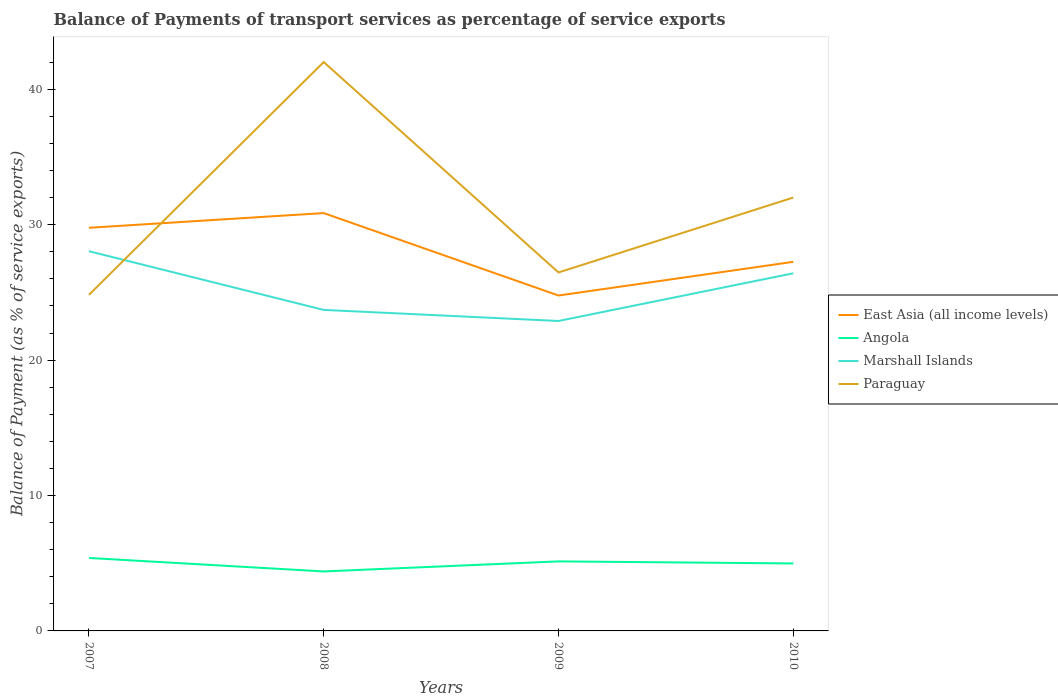Across all years, what is the maximum balance of payments of transport services in Paraguay?
Keep it short and to the point. 24.82. What is the total balance of payments of transport services in Marshall Islands in the graph?
Your answer should be compact. 1.63. What is the difference between the highest and the second highest balance of payments of transport services in East Asia (all income levels)?
Your answer should be compact. 6.09. Is the balance of payments of transport services in East Asia (all income levels) strictly greater than the balance of payments of transport services in Paraguay over the years?
Your answer should be very brief. No. How many lines are there?
Give a very brief answer. 4. Are the values on the major ticks of Y-axis written in scientific E-notation?
Your response must be concise. No. How are the legend labels stacked?
Make the answer very short. Vertical. What is the title of the graph?
Your answer should be compact. Balance of Payments of transport services as percentage of service exports. What is the label or title of the X-axis?
Your answer should be very brief. Years. What is the label or title of the Y-axis?
Keep it short and to the point. Balance of Payment (as % of service exports). What is the Balance of Payment (as % of service exports) in East Asia (all income levels) in 2007?
Provide a short and direct response. 29.78. What is the Balance of Payment (as % of service exports) of Angola in 2007?
Provide a short and direct response. 5.39. What is the Balance of Payment (as % of service exports) in Marshall Islands in 2007?
Your response must be concise. 28.05. What is the Balance of Payment (as % of service exports) of Paraguay in 2007?
Give a very brief answer. 24.82. What is the Balance of Payment (as % of service exports) in East Asia (all income levels) in 2008?
Give a very brief answer. 30.86. What is the Balance of Payment (as % of service exports) of Angola in 2008?
Make the answer very short. 4.39. What is the Balance of Payment (as % of service exports) of Marshall Islands in 2008?
Provide a succinct answer. 23.71. What is the Balance of Payment (as % of service exports) in Paraguay in 2008?
Give a very brief answer. 42.02. What is the Balance of Payment (as % of service exports) in East Asia (all income levels) in 2009?
Make the answer very short. 24.77. What is the Balance of Payment (as % of service exports) of Angola in 2009?
Offer a terse response. 5.14. What is the Balance of Payment (as % of service exports) in Marshall Islands in 2009?
Your answer should be compact. 22.89. What is the Balance of Payment (as % of service exports) of Paraguay in 2009?
Provide a short and direct response. 26.48. What is the Balance of Payment (as % of service exports) in East Asia (all income levels) in 2010?
Give a very brief answer. 27.26. What is the Balance of Payment (as % of service exports) of Angola in 2010?
Make the answer very short. 4.98. What is the Balance of Payment (as % of service exports) in Marshall Islands in 2010?
Give a very brief answer. 26.41. What is the Balance of Payment (as % of service exports) of Paraguay in 2010?
Ensure brevity in your answer.  32.01. Across all years, what is the maximum Balance of Payment (as % of service exports) of East Asia (all income levels)?
Offer a terse response. 30.86. Across all years, what is the maximum Balance of Payment (as % of service exports) in Angola?
Keep it short and to the point. 5.39. Across all years, what is the maximum Balance of Payment (as % of service exports) of Marshall Islands?
Offer a terse response. 28.05. Across all years, what is the maximum Balance of Payment (as % of service exports) of Paraguay?
Make the answer very short. 42.02. Across all years, what is the minimum Balance of Payment (as % of service exports) in East Asia (all income levels)?
Provide a succinct answer. 24.77. Across all years, what is the minimum Balance of Payment (as % of service exports) of Angola?
Make the answer very short. 4.39. Across all years, what is the minimum Balance of Payment (as % of service exports) of Marshall Islands?
Give a very brief answer. 22.89. Across all years, what is the minimum Balance of Payment (as % of service exports) of Paraguay?
Give a very brief answer. 24.82. What is the total Balance of Payment (as % of service exports) in East Asia (all income levels) in the graph?
Provide a succinct answer. 112.67. What is the total Balance of Payment (as % of service exports) in Angola in the graph?
Provide a short and direct response. 19.9. What is the total Balance of Payment (as % of service exports) of Marshall Islands in the graph?
Ensure brevity in your answer.  101.06. What is the total Balance of Payment (as % of service exports) in Paraguay in the graph?
Keep it short and to the point. 125.32. What is the difference between the Balance of Payment (as % of service exports) of East Asia (all income levels) in 2007 and that in 2008?
Give a very brief answer. -1.09. What is the difference between the Balance of Payment (as % of service exports) in Angola in 2007 and that in 2008?
Give a very brief answer. 1. What is the difference between the Balance of Payment (as % of service exports) in Marshall Islands in 2007 and that in 2008?
Your response must be concise. 4.34. What is the difference between the Balance of Payment (as % of service exports) of Paraguay in 2007 and that in 2008?
Offer a very short reply. -17.2. What is the difference between the Balance of Payment (as % of service exports) of East Asia (all income levels) in 2007 and that in 2009?
Your answer should be very brief. 5. What is the difference between the Balance of Payment (as % of service exports) in Angola in 2007 and that in 2009?
Keep it short and to the point. 0.25. What is the difference between the Balance of Payment (as % of service exports) in Marshall Islands in 2007 and that in 2009?
Give a very brief answer. 5.15. What is the difference between the Balance of Payment (as % of service exports) of Paraguay in 2007 and that in 2009?
Keep it short and to the point. -1.65. What is the difference between the Balance of Payment (as % of service exports) of East Asia (all income levels) in 2007 and that in 2010?
Offer a terse response. 2.51. What is the difference between the Balance of Payment (as % of service exports) of Angola in 2007 and that in 2010?
Offer a very short reply. 0.41. What is the difference between the Balance of Payment (as % of service exports) in Marshall Islands in 2007 and that in 2010?
Your response must be concise. 1.63. What is the difference between the Balance of Payment (as % of service exports) in Paraguay in 2007 and that in 2010?
Provide a short and direct response. -7.19. What is the difference between the Balance of Payment (as % of service exports) in East Asia (all income levels) in 2008 and that in 2009?
Give a very brief answer. 6.09. What is the difference between the Balance of Payment (as % of service exports) of Angola in 2008 and that in 2009?
Your response must be concise. -0.74. What is the difference between the Balance of Payment (as % of service exports) in Marshall Islands in 2008 and that in 2009?
Offer a very short reply. 0.82. What is the difference between the Balance of Payment (as % of service exports) in Paraguay in 2008 and that in 2009?
Keep it short and to the point. 15.54. What is the difference between the Balance of Payment (as % of service exports) of East Asia (all income levels) in 2008 and that in 2010?
Your response must be concise. 3.6. What is the difference between the Balance of Payment (as % of service exports) in Angola in 2008 and that in 2010?
Your answer should be compact. -0.59. What is the difference between the Balance of Payment (as % of service exports) of Marshall Islands in 2008 and that in 2010?
Give a very brief answer. -2.7. What is the difference between the Balance of Payment (as % of service exports) of Paraguay in 2008 and that in 2010?
Your answer should be compact. 10.01. What is the difference between the Balance of Payment (as % of service exports) of East Asia (all income levels) in 2009 and that in 2010?
Ensure brevity in your answer.  -2.49. What is the difference between the Balance of Payment (as % of service exports) in Angola in 2009 and that in 2010?
Your answer should be very brief. 0.15. What is the difference between the Balance of Payment (as % of service exports) of Marshall Islands in 2009 and that in 2010?
Ensure brevity in your answer.  -3.52. What is the difference between the Balance of Payment (as % of service exports) of Paraguay in 2009 and that in 2010?
Your answer should be very brief. -5.53. What is the difference between the Balance of Payment (as % of service exports) of East Asia (all income levels) in 2007 and the Balance of Payment (as % of service exports) of Angola in 2008?
Your answer should be very brief. 25.38. What is the difference between the Balance of Payment (as % of service exports) in East Asia (all income levels) in 2007 and the Balance of Payment (as % of service exports) in Marshall Islands in 2008?
Give a very brief answer. 6.07. What is the difference between the Balance of Payment (as % of service exports) in East Asia (all income levels) in 2007 and the Balance of Payment (as % of service exports) in Paraguay in 2008?
Offer a very short reply. -12.24. What is the difference between the Balance of Payment (as % of service exports) of Angola in 2007 and the Balance of Payment (as % of service exports) of Marshall Islands in 2008?
Your response must be concise. -18.32. What is the difference between the Balance of Payment (as % of service exports) in Angola in 2007 and the Balance of Payment (as % of service exports) in Paraguay in 2008?
Keep it short and to the point. -36.63. What is the difference between the Balance of Payment (as % of service exports) in Marshall Islands in 2007 and the Balance of Payment (as % of service exports) in Paraguay in 2008?
Your answer should be very brief. -13.97. What is the difference between the Balance of Payment (as % of service exports) of East Asia (all income levels) in 2007 and the Balance of Payment (as % of service exports) of Angola in 2009?
Keep it short and to the point. 24.64. What is the difference between the Balance of Payment (as % of service exports) in East Asia (all income levels) in 2007 and the Balance of Payment (as % of service exports) in Marshall Islands in 2009?
Your answer should be very brief. 6.88. What is the difference between the Balance of Payment (as % of service exports) of East Asia (all income levels) in 2007 and the Balance of Payment (as % of service exports) of Paraguay in 2009?
Your answer should be compact. 3.3. What is the difference between the Balance of Payment (as % of service exports) of Angola in 2007 and the Balance of Payment (as % of service exports) of Marshall Islands in 2009?
Ensure brevity in your answer.  -17.5. What is the difference between the Balance of Payment (as % of service exports) of Angola in 2007 and the Balance of Payment (as % of service exports) of Paraguay in 2009?
Your response must be concise. -21.09. What is the difference between the Balance of Payment (as % of service exports) of Marshall Islands in 2007 and the Balance of Payment (as % of service exports) of Paraguay in 2009?
Give a very brief answer. 1.57. What is the difference between the Balance of Payment (as % of service exports) of East Asia (all income levels) in 2007 and the Balance of Payment (as % of service exports) of Angola in 2010?
Offer a very short reply. 24.79. What is the difference between the Balance of Payment (as % of service exports) in East Asia (all income levels) in 2007 and the Balance of Payment (as % of service exports) in Marshall Islands in 2010?
Offer a very short reply. 3.36. What is the difference between the Balance of Payment (as % of service exports) in East Asia (all income levels) in 2007 and the Balance of Payment (as % of service exports) in Paraguay in 2010?
Provide a succinct answer. -2.23. What is the difference between the Balance of Payment (as % of service exports) of Angola in 2007 and the Balance of Payment (as % of service exports) of Marshall Islands in 2010?
Give a very brief answer. -21.02. What is the difference between the Balance of Payment (as % of service exports) in Angola in 2007 and the Balance of Payment (as % of service exports) in Paraguay in 2010?
Offer a terse response. -26.62. What is the difference between the Balance of Payment (as % of service exports) in Marshall Islands in 2007 and the Balance of Payment (as % of service exports) in Paraguay in 2010?
Provide a succinct answer. -3.96. What is the difference between the Balance of Payment (as % of service exports) of East Asia (all income levels) in 2008 and the Balance of Payment (as % of service exports) of Angola in 2009?
Provide a short and direct response. 25.73. What is the difference between the Balance of Payment (as % of service exports) in East Asia (all income levels) in 2008 and the Balance of Payment (as % of service exports) in Marshall Islands in 2009?
Your answer should be compact. 7.97. What is the difference between the Balance of Payment (as % of service exports) of East Asia (all income levels) in 2008 and the Balance of Payment (as % of service exports) of Paraguay in 2009?
Your answer should be very brief. 4.39. What is the difference between the Balance of Payment (as % of service exports) in Angola in 2008 and the Balance of Payment (as % of service exports) in Marshall Islands in 2009?
Your response must be concise. -18.5. What is the difference between the Balance of Payment (as % of service exports) of Angola in 2008 and the Balance of Payment (as % of service exports) of Paraguay in 2009?
Your response must be concise. -22.08. What is the difference between the Balance of Payment (as % of service exports) in Marshall Islands in 2008 and the Balance of Payment (as % of service exports) in Paraguay in 2009?
Offer a very short reply. -2.77. What is the difference between the Balance of Payment (as % of service exports) in East Asia (all income levels) in 2008 and the Balance of Payment (as % of service exports) in Angola in 2010?
Your answer should be very brief. 25.88. What is the difference between the Balance of Payment (as % of service exports) in East Asia (all income levels) in 2008 and the Balance of Payment (as % of service exports) in Marshall Islands in 2010?
Your response must be concise. 4.45. What is the difference between the Balance of Payment (as % of service exports) in East Asia (all income levels) in 2008 and the Balance of Payment (as % of service exports) in Paraguay in 2010?
Offer a very short reply. -1.15. What is the difference between the Balance of Payment (as % of service exports) in Angola in 2008 and the Balance of Payment (as % of service exports) in Marshall Islands in 2010?
Your response must be concise. -22.02. What is the difference between the Balance of Payment (as % of service exports) of Angola in 2008 and the Balance of Payment (as % of service exports) of Paraguay in 2010?
Provide a short and direct response. -27.62. What is the difference between the Balance of Payment (as % of service exports) in Marshall Islands in 2008 and the Balance of Payment (as % of service exports) in Paraguay in 2010?
Give a very brief answer. -8.3. What is the difference between the Balance of Payment (as % of service exports) in East Asia (all income levels) in 2009 and the Balance of Payment (as % of service exports) in Angola in 2010?
Your answer should be compact. 19.79. What is the difference between the Balance of Payment (as % of service exports) in East Asia (all income levels) in 2009 and the Balance of Payment (as % of service exports) in Marshall Islands in 2010?
Your response must be concise. -1.64. What is the difference between the Balance of Payment (as % of service exports) in East Asia (all income levels) in 2009 and the Balance of Payment (as % of service exports) in Paraguay in 2010?
Give a very brief answer. -7.24. What is the difference between the Balance of Payment (as % of service exports) in Angola in 2009 and the Balance of Payment (as % of service exports) in Marshall Islands in 2010?
Give a very brief answer. -21.28. What is the difference between the Balance of Payment (as % of service exports) of Angola in 2009 and the Balance of Payment (as % of service exports) of Paraguay in 2010?
Ensure brevity in your answer.  -26.87. What is the difference between the Balance of Payment (as % of service exports) of Marshall Islands in 2009 and the Balance of Payment (as % of service exports) of Paraguay in 2010?
Provide a succinct answer. -9.12. What is the average Balance of Payment (as % of service exports) in East Asia (all income levels) per year?
Your response must be concise. 28.17. What is the average Balance of Payment (as % of service exports) of Angola per year?
Your answer should be compact. 4.98. What is the average Balance of Payment (as % of service exports) of Marshall Islands per year?
Your response must be concise. 25.27. What is the average Balance of Payment (as % of service exports) in Paraguay per year?
Offer a very short reply. 31.33. In the year 2007, what is the difference between the Balance of Payment (as % of service exports) of East Asia (all income levels) and Balance of Payment (as % of service exports) of Angola?
Keep it short and to the point. 24.39. In the year 2007, what is the difference between the Balance of Payment (as % of service exports) of East Asia (all income levels) and Balance of Payment (as % of service exports) of Marshall Islands?
Your answer should be very brief. 1.73. In the year 2007, what is the difference between the Balance of Payment (as % of service exports) of East Asia (all income levels) and Balance of Payment (as % of service exports) of Paraguay?
Make the answer very short. 4.95. In the year 2007, what is the difference between the Balance of Payment (as % of service exports) in Angola and Balance of Payment (as % of service exports) in Marshall Islands?
Your response must be concise. -22.66. In the year 2007, what is the difference between the Balance of Payment (as % of service exports) in Angola and Balance of Payment (as % of service exports) in Paraguay?
Your answer should be very brief. -19.43. In the year 2007, what is the difference between the Balance of Payment (as % of service exports) of Marshall Islands and Balance of Payment (as % of service exports) of Paraguay?
Give a very brief answer. 3.22. In the year 2008, what is the difference between the Balance of Payment (as % of service exports) in East Asia (all income levels) and Balance of Payment (as % of service exports) in Angola?
Make the answer very short. 26.47. In the year 2008, what is the difference between the Balance of Payment (as % of service exports) in East Asia (all income levels) and Balance of Payment (as % of service exports) in Marshall Islands?
Make the answer very short. 7.15. In the year 2008, what is the difference between the Balance of Payment (as % of service exports) of East Asia (all income levels) and Balance of Payment (as % of service exports) of Paraguay?
Provide a short and direct response. -11.16. In the year 2008, what is the difference between the Balance of Payment (as % of service exports) of Angola and Balance of Payment (as % of service exports) of Marshall Islands?
Keep it short and to the point. -19.32. In the year 2008, what is the difference between the Balance of Payment (as % of service exports) in Angola and Balance of Payment (as % of service exports) in Paraguay?
Offer a terse response. -37.62. In the year 2008, what is the difference between the Balance of Payment (as % of service exports) in Marshall Islands and Balance of Payment (as % of service exports) in Paraguay?
Your response must be concise. -18.31. In the year 2009, what is the difference between the Balance of Payment (as % of service exports) of East Asia (all income levels) and Balance of Payment (as % of service exports) of Angola?
Provide a succinct answer. 19.64. In the year 2009, what is the difference between the Balance of Payment (as % of service exports) of East Asia (all income levels) and Balance of Payment (as % of service exports) of Marshall Islands?
Give a very brief answer. 1.88. In the year 2009, what is the difference between the Balance of Payment (as % of service exports) of East Asia (all income levels) and Balance of Payment (as % of service exports) of Paraguay?
Your answer should be very brief. -1.7. In the year 2009, what is the difference between the Balance of Payment (as % of service exports) of Angola and Balance of Payment (as % of service exports) of Marshall Islands?
Your answer should be very brief. -17.76. In the year 2009, what is the difference between the Balance of Payment (as % of service exports) in Angola and Balance of Payment (as % of service exports) in Paraguay?
Provide a short and direct response. -21.34. In the year 2009, what is the difference between the Balance of Payment (as % of service exports) in Marshall Islands and Balance of Payment (as % of service exports) in Paraguay?
Make the answer very short. -3.58. In the year 2010, what is the difference between the Balance of Payment (as % of service exports) in East Asia (all income levels) and Balance of Payment (as % of service exports) in Angola?
Keep it short and to the point. 22.28. In the year 2010, what is the difference between the Balance of Payment (as % of service exports) in East Asia (all income levels) and Balance of Payment (as % of service exports) in Marshall Islands?
Make the answer very short. 0.85. In the year 2010, what is the difference between the Balance of Payment (as % of service exports) in East Asia (all income levels) and Balance of Payment (as % of service exports) in Paraguay?
Give a very brief answer. -4.75. In the year 2010, what is the difference between the Balance of Payment (as % of service exports) in Angola and Balance of Payment (as % of service exports) in Marshall Islands?
Your response must be concise. -21.43. In the year 2010, what is the difference between the Balance of Payment (as % of service exports) of Angola and Balance of Payment (as % of service exports) of Paraguay?
Provide a succinct answer. -27.02. In the year 2010, what is the difference between the Balance of Payment (as % of service exports) of Marshall Islands and Balance of Payment (as % of service exports) of Paraguay?
Offer a very short reply. -5.59. What is the ratio of the Balance of Payment (as % of service exports) of East Asia (all income levels) in 2007 to that in 2008?
Provide a short and direct response. 0.96. What is the ratio of the Balance of Payment (as % of service exports) in Angola in 2007 to that in 2008?
Keep it short and to the point. 1.23. What is the ratio of the Balance of Payment (as % of service exports) in Marshall Islands in 2007 to that in 2008?
Offer a terse response. 1.18. What is the ratio of the Balance of Payment (as % of service exports) in Paraguay in 2007 to that in 2008?
Make the answer very short. 0.59. What is the ratio of the Balance of Payment (as % of service exports) in East Asia (all income levels) in 2007 to that in 2009?
Give a very brief answer. 1.2. What is the ratio of the Balance of Payment (as % of service exports) of Angola in 2007 to that in 2009?
Your response must be concise. 1.05. What is the ratio of the Balance of Payment (as % of service exports) of Marshall Islands in 2007 to that in 2009?
Ensure brevity in your answer.  1.23. What is the ratio of the Balance of Payment (as % of service exports) in East Asia (all income levels) in 2007 to that in 2010?
Your answer should be very brief. 1.09. What is the ratio of the Balance of Payment (as % of service exports) in Angola in 2007 to that in 2010?
Give a very brief answer. 1.08. What is the ratio of the Balance of Payment (as % of service exports) in Marshall Islands in 2007 to that in 2010?
Your answer should be very brief. 1.06. What is the ratio of the Balance of Payment (as % of service exports) in Paraguay in 2007 to that in 2010?
Ensure brevity in your answer.  0.78. What is the ratio of the Balance of Payment (as % of service exports) in East Asia (all income levels) in 2008 to that in 2009?
Ensure brevity in your answer.  1.25. What is the ratio of the Balance of Payment (as % of service exports) in Angola in 2008 to that in 2009?
Offer a terse response. 0.86. What is the ratio of the Balance of Payment (as % of service exports) of Marshall Islands in 2008 to that in 2009?
Your answer should be very brief. 1.04. What is the ratio of the Balance of Payment (as % of service exports) in Paraguay in 2008 to that in 2009?
Make the answer very short. 1.59. What is the ratio of the Balance of Payment (as % of service exports) of East Asia (all income levels) in 2008 to that in 2010?
Offer a very short reply. 1.13. What is the ratio of the Balance of Payment (as % of service exports) of Angola in 2008 to that in 2010?
Keep it short and to the point. 0.88. What is the ratio of the Balance of Payment (as % of service exports) of Marshall Islands in 2008 to that in 2010?
Your response must be concise. 0.9. What is the ratio of the Balance of Payment (as % of service exports) in Paraguay in 2008 to that in 2010?
Make the answer very short. 1.31. What is the ratio of the Balance of Payment (as % of service exports) in East Asia (all income levels) in 2009 to that in 2010?
Provide a succinct answer. 0.91. What is the ratio of the Balance of Payment (as % of service exports) of Angola in 2009 to that in 2010?
Your answer should be compact. 1.03. What is the ratio of the Balance of Payment (as % of service exports) of Marshall Islands in 2009 to that in 2010?
Provide a succinct answer. 0.87. What is the ratio of the Balance of Payment (as % of service exports) of Paraguay in 2009 to that in 2010?
Provide a short and direct response. 0.83. What is the difference between the highest and the second highest Balance of Payment (as % of service exports) of East Asia (all income levels)?
Your answer should be compact. 1.09. What is the difference between the highest and the second highest Balance of Payment (as % of service exports) of Angola?
Offer a very short reply. 0.25. What is the difference between the highest and the second highest Balance of Payment (as % of service exports) of Marshall Islands?
Ensure brevity in your answer.  1.63. What is the difference between the highest and the second highest Balance of Payment (as % of service exports) of Paraguay?
Your answer should be very brief. 10.01. What is the difference between the highest and the lowest Balance of Payment (as % of service exports) in East Asia (all income levels)?
Your answer should be compact. 6.09. What is the difference between the highest and the lowest Balance of Payment (as % of service exports) in Angola?
Your answer should be very brief. 1. What is the difference between the highest and the lowest Balance of Payment (as % of service exports) in Marshall Islands?
Make the answer very short. 5.15. What is the difference between the highest and the lowest Balance of Payment (as % of service exports) of Paraguay?
Your response must be concise. 17.2. 